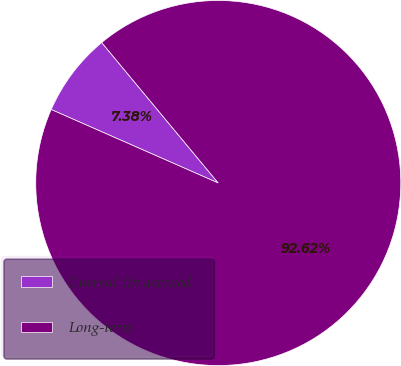Convert chart. <chart><loc_0><loc_0><loc_500><loc_500><pie_chart><fcel>Current (in accrued<fcel>Long-term<nl><fcel>7.38%<fcel>92.62%<nl></chart> 